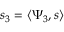<formula> <loc_0><loc_0><loc_500><loc_500>s _ { 3 } = \langle \Psi _ { 3 } , s \rangle</formula> 